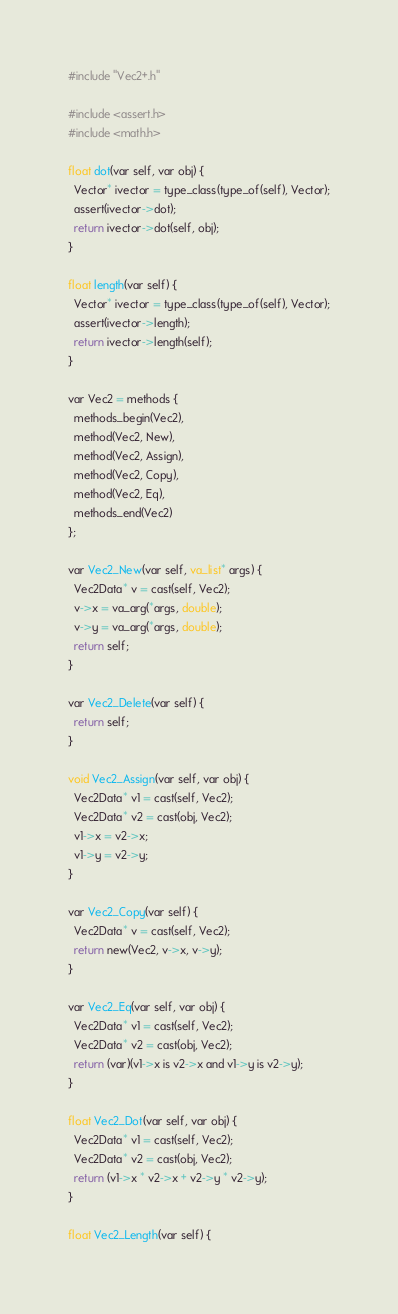<code> <loc_0><loc_0><loc_500><loc_500><_C_>#include "Vec2+.h"

#include <assert.h>
#include <math.h>

float dot(var self, var obj) {
  Vector* ivector = type_class(type_of(self), Vector);
  assert(ivector->dot);
  return ivector->dot(self, obj);
}

float length(var self) {
  Vector* ivector = type_class(type_of(self), Vector);
  assert(ivector->length);
  return ivector->length(self);
}

var Vec2 = methods {
  methods_begin(Vec2),
  method(Vec2, New),
  method(Vec2, Assign),
  method(Vec2, Copy),
  method(Vec2, Eq),
  methods_end(Vec2)
};

var Vec2_New(var self, va_list* args) {
  Vec2Data* v = cast(self, Vec2);
  v->x = va_arg(*args, double);
  v->y = va_arg(*args, double);
  return self;
}

var Vec2_Delete(var self) {
  return self;
}

void Vec2_Assign(var self, var obj) {
  Vec2Data* v1 = cast(self, Vec2);
  Vec2Data* v2 = cast(obj, Vec2);
  v1->x = v2->x;
  v1->y = v2->y;
}

var Vec2_Copy(var self) {
  Vec2Data* v = cast(self, Vec2);
  return new(Vec2, v->x, v->y);
}

var Vec2_Eq(var self, var obj) {
  Vec2Data* v1 = cast(self, Vec2);
  Vec2Data* v2 = cast(obj, Vec2);
  return (var)(v1->x is v2->x and v1->y is v2->y);
}

float Vec2_Dot(var self, var obj) {
  Vec2Data* v1 = cast(self, Vec2);
  Vec2Data* v2 = cast(obj, Vec2);
  return (v1->x * v2->x + v2->y * v2->y);
}

float Vec2_Length(var self) {</code> 